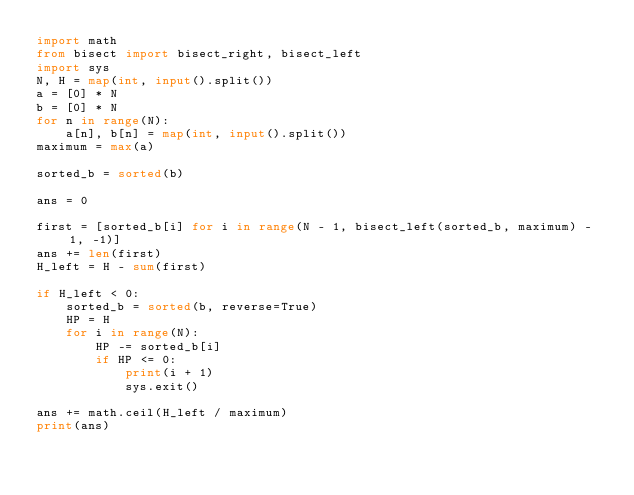<code> <loc_0><loc_0><loc_500><loc_500><_Python_>import math
from bisect import bisect_right, bisect_left
import sys
N, H = map(int, input().split())
a = [0] * N
b = [0] * N
for n in range(N):
    a[n], b[n] = map(int, input().split())
maximum = max(a)

sorted_b = sorted(b)

ans = 0

first = [sorted_b[i] for i in range(N - 1, bisect_left(sorted_b, maximum) - 1, -1)]
ans += len(first)
H_left = H - sum(first)

if H_left < 0:
    sorted_b = sorted(b, reverse=True)
    HP = H
    for i in range(N):
        HP -= sorted_b[i]
        if HP <= 0:
            print(i + 1)
            sys.exit()

ans += math.ceil(H_left / maximum)
print(ans)</code> 